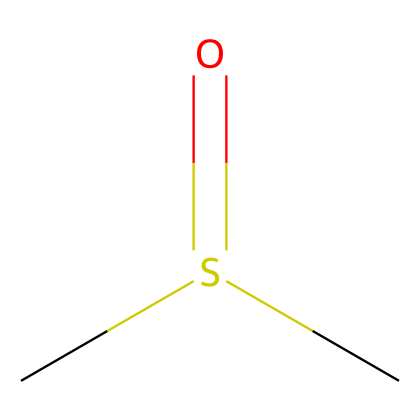What is the molecular formula of this compound? The SMILES representation indicates that the compound consists of two carbon atoms (C), one sulfur atom (S), and one oxygen atom (O), leading to the molecular formula of C2H6OS.
Answer: C2H6OS How many hydrogen atoms are present in dimethyl sulfoxide? Analyzing the SMILES structure, there are six hydrogen atoms surrounding the two carbon atoms.
Answer: 6 What functional group is represented in this structure? The presence of the sulfur atom bonded to an oxygen atom with a double bond, along with the carbon atoms, indicates that this compound contains a sulfoxide functional group.
Answer: sulfoxide How many double bonds are there in this compound? The SMILES notation shows one double bond between the sulfur and the oxygen, indicating that there is one double bond present in the structure.
Answer: 1 Which element in this compound contributes to its organosulfur classification? The presence of the sulfur atom (S) in the molecular structure is what classifies this compound as an organosulfur compound.
Answer: sulfur What type of bond connects the sulfur and oxygen atoms in this molecule? The SMILES structure indicates a double bond between the sulfur and oxygen atoms, as indicated by the "S(=O)" part of the representation.
Answer: double bond 